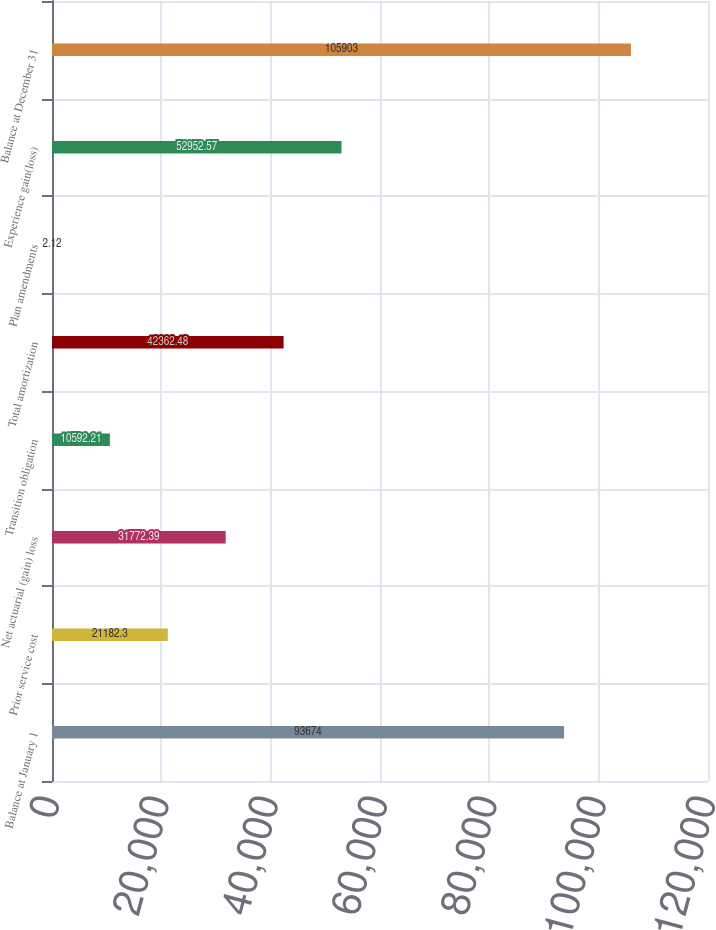<chart> <loc_0><loc_0><loc_500><loc_500><bar_chart><fcel>Balance at January 1<fcel>Prior service cost<fcel>Net actuarial (gain) loss<fcel>Transition obligation<fcel>Total amortization<fcel>Plan amendments<fcel>Experience gain(loss)<fcel>Balance at December 31<nl><fcel>93674<fcel>21182.3<fcel>31772.4<fcel>10592.2<fcel>42362.5<fcel>2.12<fcel>52952.6<fcel>105903<nl></chart> 